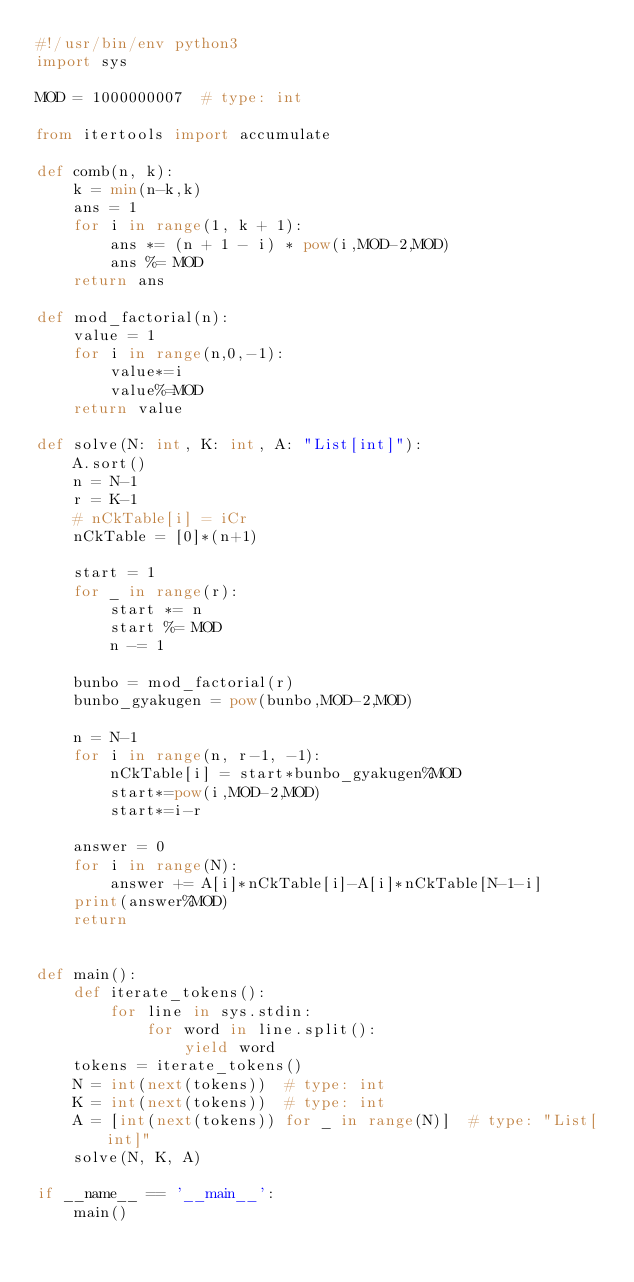<code> <loc_0><loc_0><loc_500><loc_500><_Python_>#!/usr/bin/env python3
import sys

MOD = 1000000007  # type: int

from itertools import accumulate

def comb(n, k):
    k = min(n-k,k)
    ans = 1
    for i in range(1, k + 1):
        ans *= (n + 1 - i) * pow(i,MOD-2,MOD)
        ans %= MOD
    return ans

def mod_factorial(n):
    value = 1
    for i in range(n,0,-1):
        value*=i
        value%=MOD
    return value

def solve(N: int, K: int, A: "List[int]"):
    A.sort()
    n = N-1
    r = K-1
    # nCkTable[i] = iCr
    nCkTable = [0]*(n+1)

    start = 1
    for _ in range(r):
        start *= n
        start %= MOD
        n -= 1

    bunbo = mod_factorial(r)
    bunbo_gyakugen = pow(bunbo,MOD-2,MOD)

    n = N-1
    for i in range(n, r-1, -1):
        nCkTable[i] = start*bunbo_gyakugen%MOD
        start*=pow(i,MOD-2,MOD)
        start*=i-r

    answer = 0
    for i in range(N):
        answer += A[i]*nCkTable[i]-A[i]*nCkTable[N-1-i]
    print(answer%MOD)
    return


def main():
    def iterate_tokens():
        for line in sys.stdin:
            for word in line.split():
                yield word
    tokens = iterate_tokens()
    N = int(next(tokens))  # type: int
    K = int(next(tokens))  # type: int
    A = [int(next(tokens)) for _ in range(N)]  # type: "List[int]"
    solve(N, K, A)

if __name__ == '__main__':
    main()
</code> 